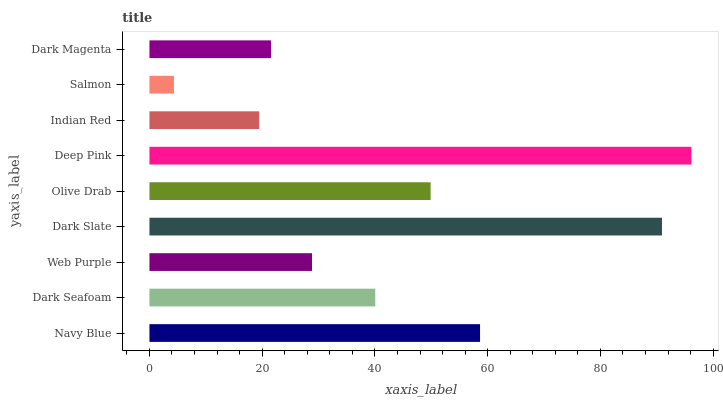Is Salmon the minimum?
Answer yes or no. Yes. Is Deep Pink the maximum?
Answer yes or no. Yes. Is Dark Seafoam the minimum?
Answer yes or no. No. Is Dark Seafoam the maximum?
Answer yes or no. No. Is Navy Blue greater than Dark Seafoam?
Answer yes or no. Yes. Is Dark Seafoam less than Navy Blue?
Answer yes or no. Yes. Is Dark Seafoam greater than Navy Blue?
Answer yes or no. No. Is Navy Blue less than Dark Seafoam?
Answer yes or no. No. Is Dark Seafoam the high median?
Answer yes or no. Yes. Is Dark Seafoam the low median?
Answer yes or no. Yes. Is Dark Slate the high median?
Answer yes or no. No. Is Dark Magenta the low median?
Answer yes or no. No. 